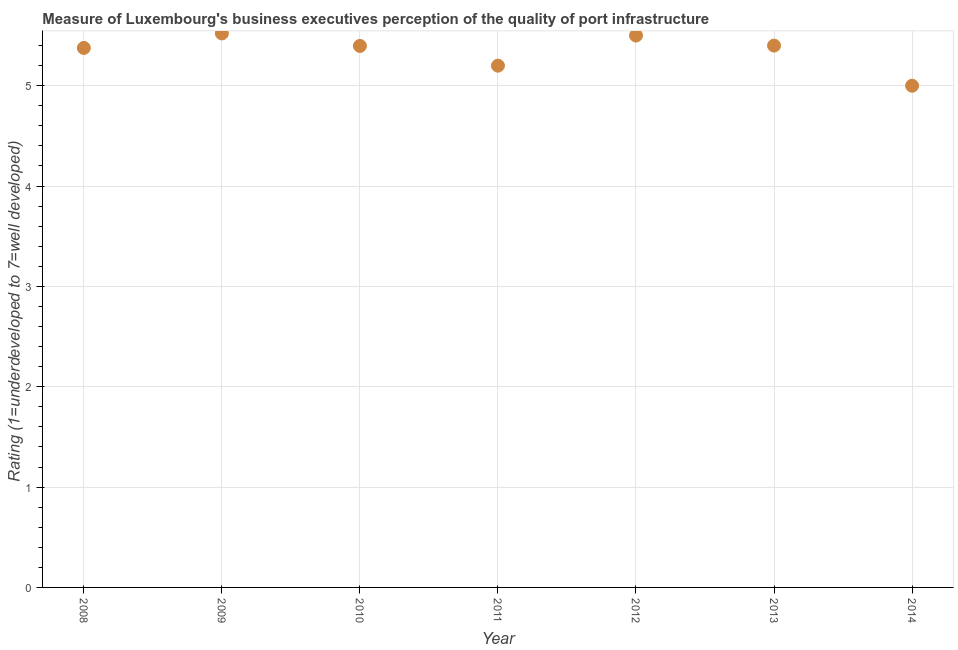Across all years, what is the maximum rating measuring quality of port infrastructure?
Make the answer very short. 5.52. In which year was the rating measuring quality of port infrastructure maximum?
Your response must be concise. 2009. In which year was the rating measuring quality of port infrastructure minimum?
Your answer should be compact. 2014. What is the sum of the rating measuring quality of port infrastructure?
Ensure brevity in your answer.  37.39. What is the difference between the rating measuring quality of port infrastructure in 2012 and 2013?
Provide a succinct answer. 0.1. What is the average rating measuring quality of port infrastructure per year?
Make the answer very short. 5.34. What is the median rating measuring quality of port infrastructure?
Give a very brief answer. 5.4. What is the ratio of the rating measuring quality of port infrastructure in 2008 to that in 2009?
Offer a very short reply. 0.97. Is the rating measuring quality of port infrastructure in 2008 less than that in 2010?
Offer a very short reply. Yes. Is the difference between the rating measuring quality of port infrastructure in 2009 and 2012 greater than the difference between any two years?
Offer a terse response. No. What is the difference between the highest and the second highest rating measuring quality of port infrastructure?
Make the answer very short. 0.02. Is the sum of the rating measuring quality of port infrastructure in 2008 and 2014 greater than the maximum rating measuring quality of port infrastructure across all years?
Offer a terse response. Yes. What is the difference between the highest and the lowest rating measuring quality of port infrastructure?
Provide a short and direct response. 0.52. Does the rating measuring quality of port infrastructure monotonically increase over the years?
Provide a succinct answer. No. How many years are there in the graph?
Provide a succinct answer. 7. What is the difference between two consecutive major ticks on the Y-axis?
Make the answer very short. 1. Does the graph contain any zero values?
Offer a terse response. No. What is the title of the graph?
Offer a terse response. Measure of Luxembourg's business executives perception of the quality of port infrastructure. What is the label or title of the Y-axis?
Provide a succinct answer. Rating (1=underdeveloped to 7=well developed) . What is the Rating (1=underdeveloped to 7=well developed)  in 2008?
Your answer should be very brief. 5.38. What is the Rating (1=underdeveloped to 7=well developed)  in 2009?
Ensure brevity in your answer.  5.52. What is the Rating (1=underdeveloped to 7=well developed)  in 2010?
Provide a short and direct response. 5.4. What is the Rating (1=underdeveloped to 7=well developed)  in 2013?
Provide a short and direct response. 5.4. What is the Rating (1=underdeveloped to 7=well developed)  in 2014?
Make the answer very short. 5. What is the difference between the Rating (1=underdeveloped to 7=well developed)  in 2008 and 2009?
Offer a very short reply. -0.14. What is the difference between the Rating (1=underdeveloped to 7=well developed)  in 2008 and 2010?
Ensure brevity in your answer.  -0.02. What is the difference between the Rating (1=underdeveloped to 7=well developed)  in 2008 and 2011?
Offer a terse response. 0.18. What is the difference between the Rating (1=underdeveloped to 7=well developed)  in 2008 and 2012?
Your answer should be compact. -0.12. What is the difference between the Rating (1=underdeveloped to 7=well developed)  in 2008 and 2013?
Keep it short and to the point. -0.02. What is the difference between the Rating (1=underdeveloped to 7=well developed)  in 2008 and 2014?
Your answer should be compact. 0.38. What is the difference between the Rating (1=underdeveloped to 7=well developed)  in 2009 and 2010?
Your answer should be compact. 0.12. What is the difference between the Rating (1=underdeveloped to 7=well developed)  in 2009 and 2011?
Ensure brevity in your answer.  0.32. What is the difference between the Rating (1=underdeveloped to 7=well developed)  in 2009 and 2012?
Make the answer very short. 0.02. What is the difference between the Rating (1=underdeveloped to 7=well developed)  in 2009 and 2013?
Keep it short and to the point. 0.12. What is the difference between the Rating (1=underdeveloped to 7=well developed)  in 2009 and 2014?
Make the answer very short. 0.52. What is the difference between the Rating (1=underdeveloped to 7=well developed)  in 2010 and 2011?
Your answer should be very brief. 0.2. What is the difference between the Rating (1=underdeveloped to 7=well developed)  in 2010 and 2012?
Your response must be concise. -0.1. What is the difference between the Rating (1=underdeveloped to 7=well developed)  in 2010 and 2013?
Your answer should be very brief. -0. What is the difference between the Rating (1=underdeveloped to 7=well developed)  in 2010 and 2014?
Ensure brevity in your answer.  0.4. What is the difference between the Rating (1=underdeveloped to 7=well developed)  in 2011 and 2012?
Make the answer very short. -0.3. What is the difference between the Rating (1=underdeveloped to 7=well developed)  in 2011 and 2014?
Offer a terse response. 0.2. What is the difference between the Rating (1=underdeveloped to 7=well developed)  in 2012 and 2014?
Your answer should be compact. 0.5. What is the difference between the Rating (1=underdeveloped to 7=well developed)  in 2013 and 2014?
Ensure brevity in your answer.  0.4. What is the ratio of the Rating (1=underdeveloped to 7=well developed)  in 2008 to that in 2010?
Your answer should be compact. 1. What is the ratio of the Rating (1=underdeveloped to 7=well developed)  in 2008 to that in 2011?
Offer a very short reply. 1.03. What is the ratio of the Rating (1=underdeveloped to 7=well developed)  in 2008 to that in 2014?
Offer a terse response. 1.07. What is the ratio of the Rating (1=underdeveloped to 7=well developed)  in 2009 to that in 2011?
Give a very brief answer. 1.06. What is the ratio of the Rating (1=underdeveloped to 7=well developed)  in 2009 to that in 2012?
Your answer should be very brief. 1. What is the ratio of the Rating (1=underdeveloped to 7=well developed)  in 2009 to that in 2013?
Offer a very short reply. 1.02. What is the ratio of the Rating (1=underdeveloped to 7=well developed)  in 2009 to that in 2014?
Provide a short and direct response. 1.1. What is the ratio of the Rating (1=underdeveloped to 7=well developed)  in 2010 to that in 2011?
Provide a short and direct response. 1.04. What is the ratio of the Rating (1=underdeveloped to 7=well developed)  in 2010 to that in 2012?
Offer a very short reply. 0.98. What is the ratio of the Rating (1=underdeveloped to 7=well developed)  in 2010 to that in 2014?
Ensure brevity in your answer.  1.08. What is the ratio of the Rating (1=underdeveloped to 7=well developed)  in 2011 to that in 2012?
Offer a terse response. 0.94. What is the ratio of the Rating (1=underdeveloped to 7=well developed)  in 2011 to that in 2013?
Give a very brief answer. 0.96. What is the ratio of the Rating (1=underdeveloped to 7=well developed)  in 2011 to that in 2014?
Provide a succinct answer. 1.04. What is the ratio of the Rating (1=underdeveloped to 7=well developed)  in 2012 to that in 2013?
Keep it short and to the point. 1.02. What is the ratio of the Rating (1=underdeveloped to 7=well developed)  in 2012 to that in 2014?
Your response must be concise. 1.1. What is the ratio of the Rating (1=underdeveloped to 7=well developed)  in 2013 to that in 2014?
Your answer should be compact. 1.08. 